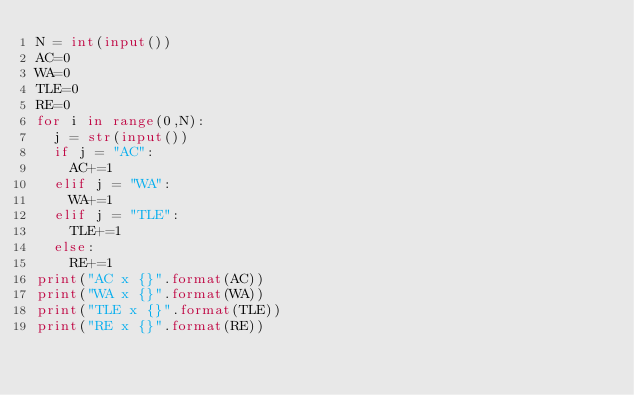<code> <loc_0><loc_0><loc_500><loc_500><_Python_>N = int(input())
AC=0
WA=0
TLE=0
RE=0
for i in range(0,N):
  j = str(input())
  if j = "AC":
    AC+=1
  elif j = "WA":
    WA+=1
  elif j = "TLE":
    TLE+=1
  else:
    RE+=1
print("AC x {}".format(AC))
print("WA x {}".format(WA))
print("TLE x {}".format(TLE))
print("RE x {}".format(RE))</code> 